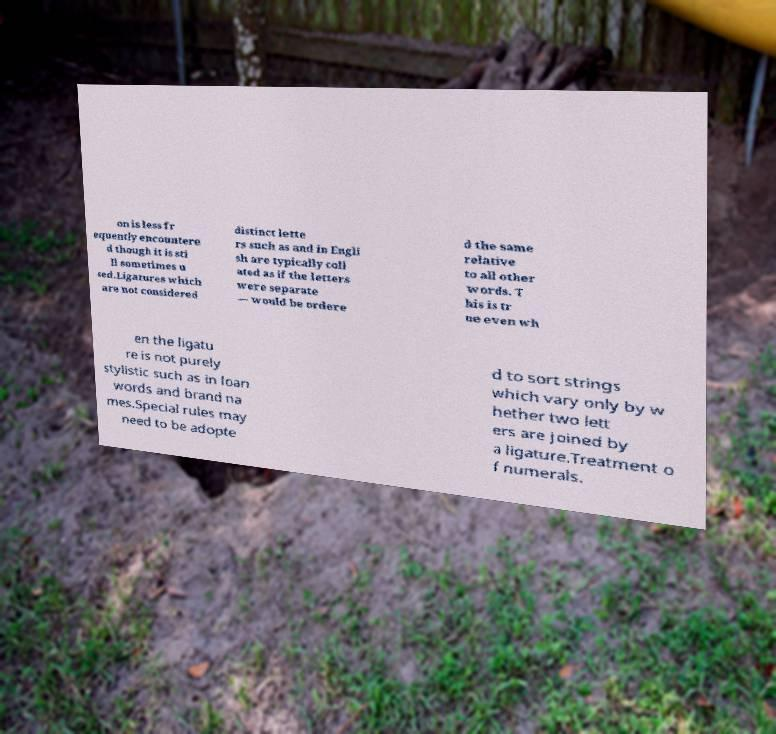Please read and relay the text visible in this image. What does it say? on is less fr equently encountere d though it is sti ll sometimes u sed.Ligatures which are not considered distinct lette rs such as and in Engli sh are typically coll ated as if the letters were separate — would be ordere d the same relative to all other words. T his is tr ue even wh en the ligatu re is not purely stylistic such as in loan words and brand na mes.Special rules may need to be adopte d to sort strings which vary only by w hether two lett ers are joined by a ligature.Treatment o f numerals. 